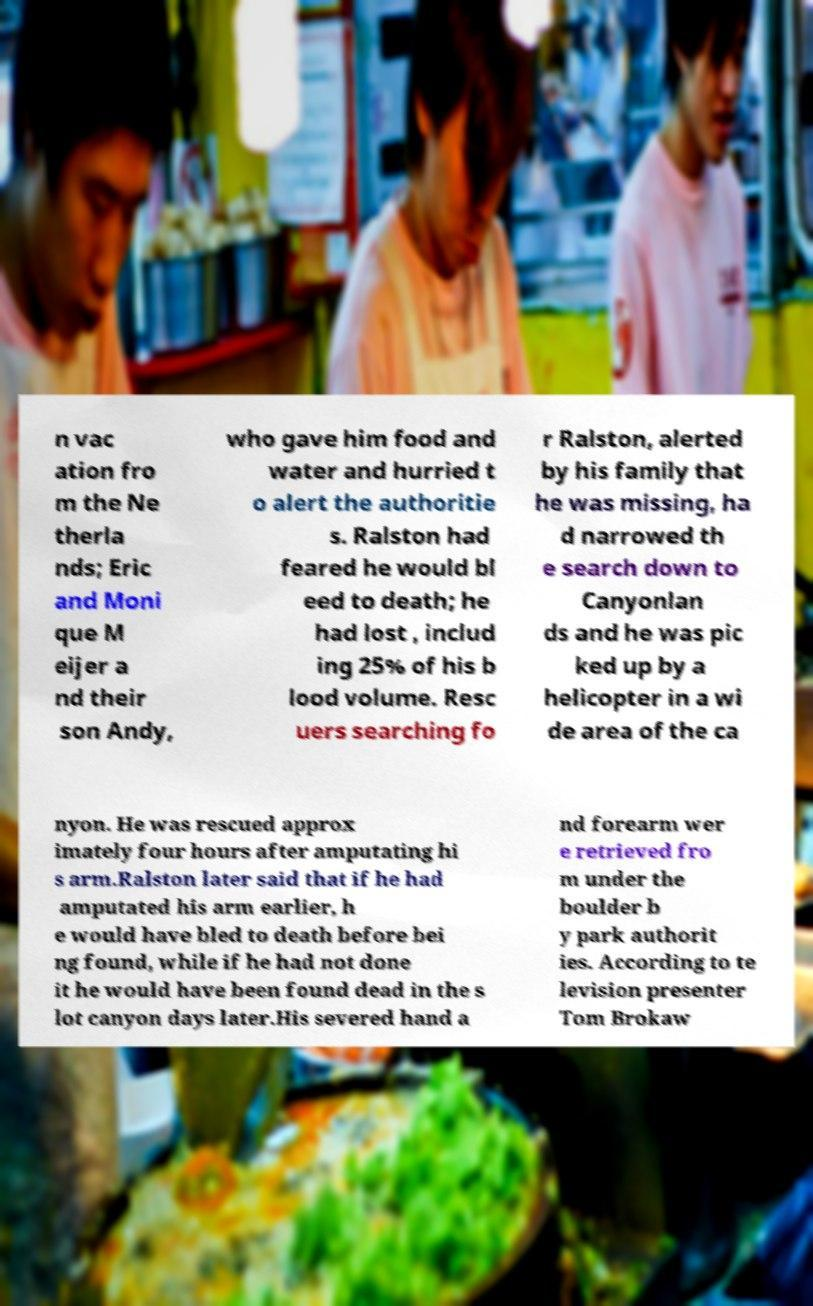Can you read and provide the text displayed in the image?This photo seems to have some interesting text. Can you extract and type it out for me? n vac ation fro m the Ne therla nds; Eric and Moni que M eijer a nd their son Andy, who gave him food and water and hurried t o alert the authoritie s. Ralston had feared he would bl eed to death; he had lost , includ ing 25% of his b lood volume. Resc uers searching fo r Ralston, alerted by his family that he was missing, ha d narrowed th e search down to Canyonlan ds and he was pic ked up by a helicopter in a wi de area of the ca nyon. He was rescued approx imately four hours after amputating hi s arm.Ralston later said that if he had amputated his arm earlier, h e would have bled to death before bei ng found, while if he had not done it he would have been found dead in the s lot canyon days later.His severed hand a nd forearm wer e retrieved fro m under the boulder b y park authorit ies. According to te levision presenter Tom Brokaw 